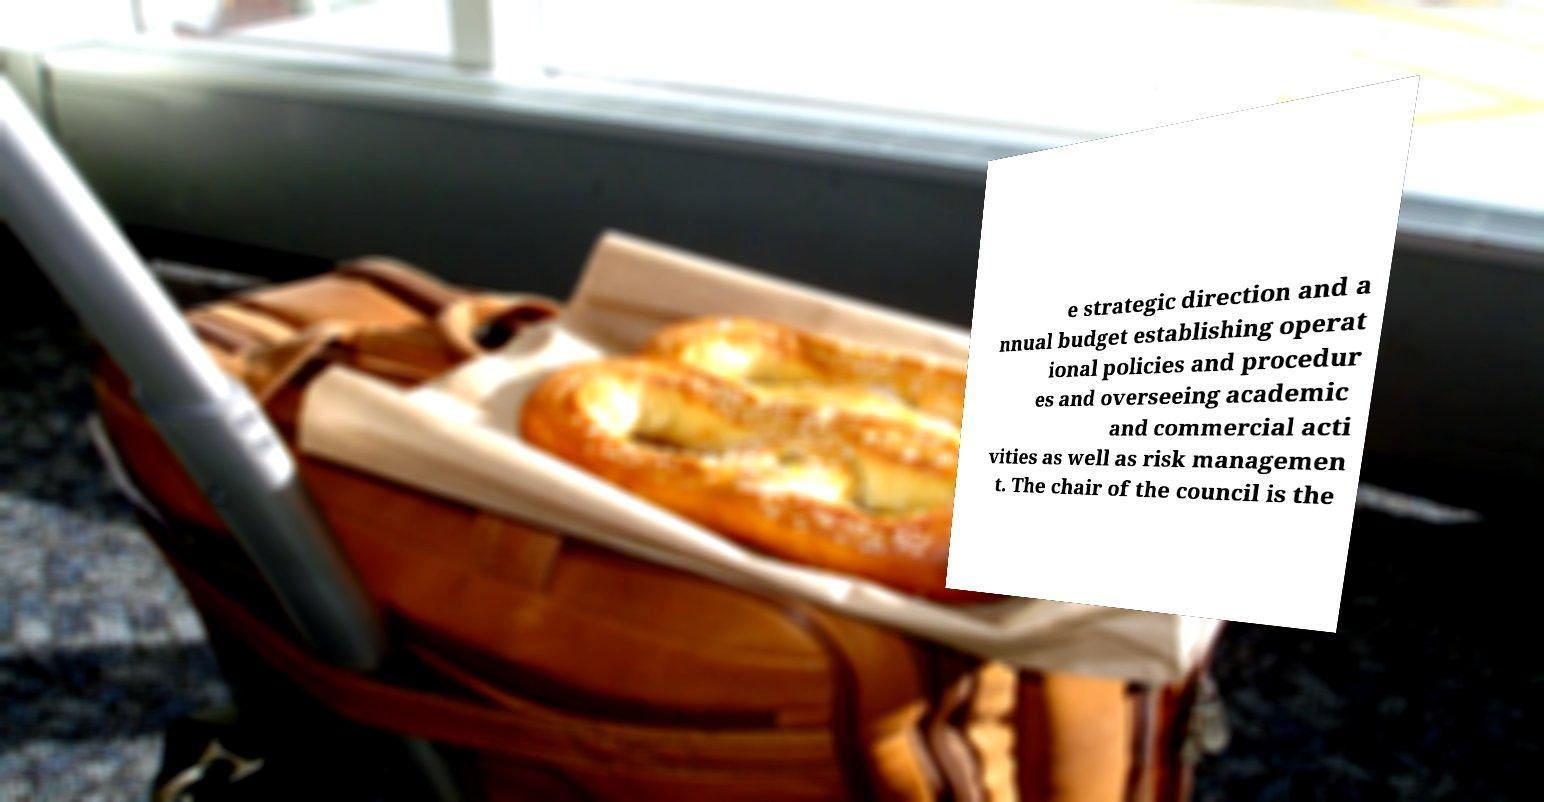Could you extract and type out the text from this image? e strategic direction and a nnual budget establishing operat ional policies and procedur es and overseeing academic and commercial acti vities as well as risk managemen t. The chair of the council is the 